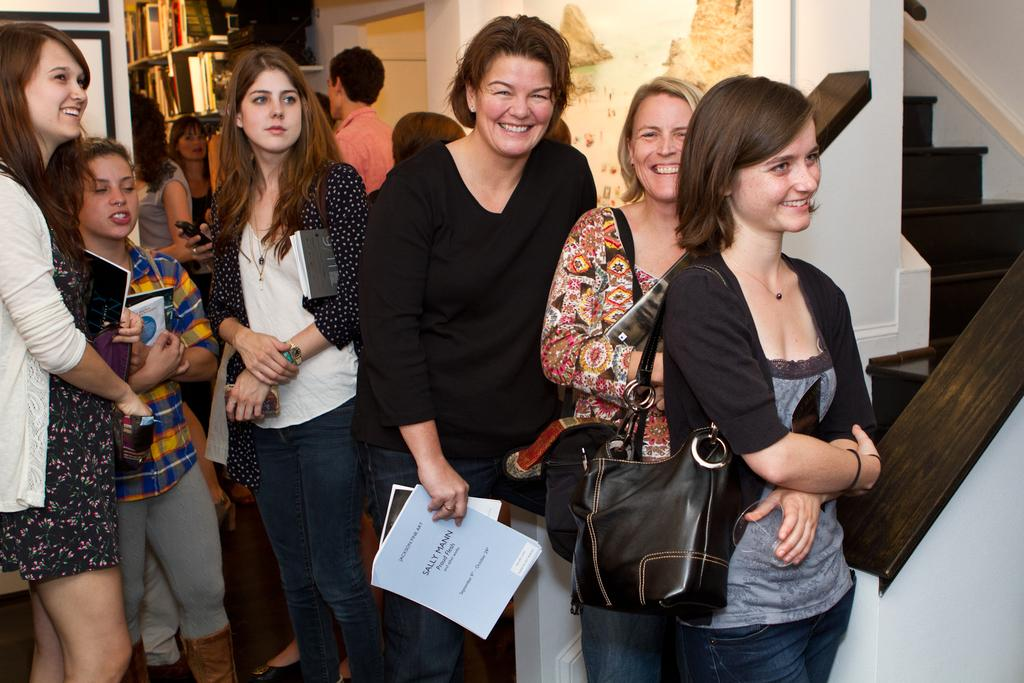What are the people in the image doing? The people in the image are standing and holding bags and papers. What objects are the people holding in the image? The people are holding bags and papers. What can be seen on the shelf in the image? The shelf contains books. What type of art can be seen on the sea in the image? There is no art or sea present in the image; it features people holding bags and papers, and a shelf with books. 